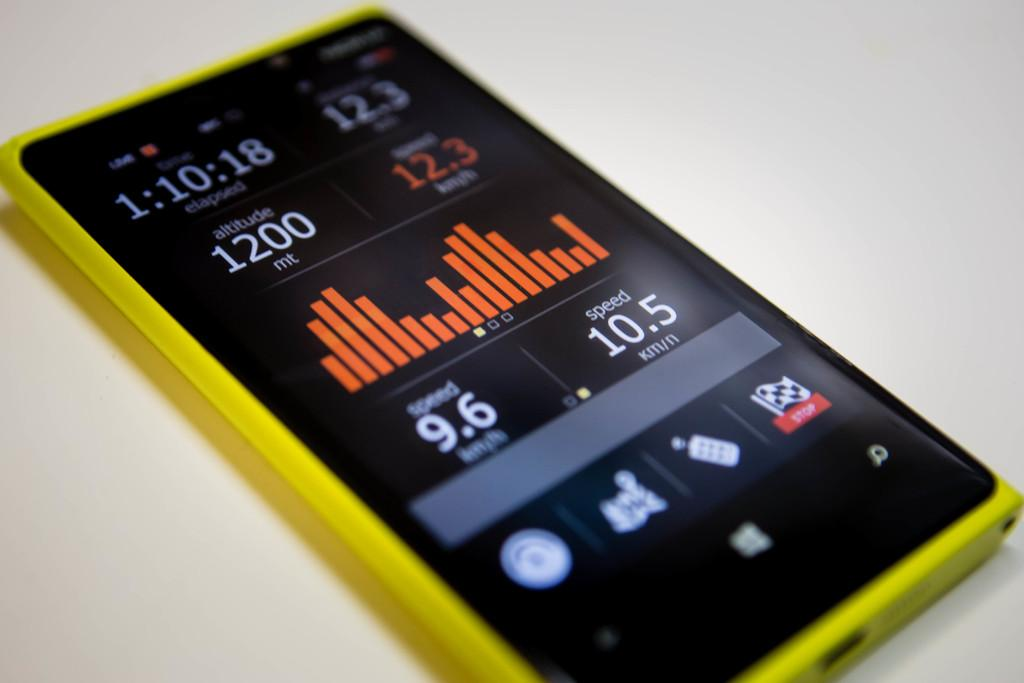Provide a one-sentence caption for the provided image. Black and yellow phone that says 12.3 in orange. 